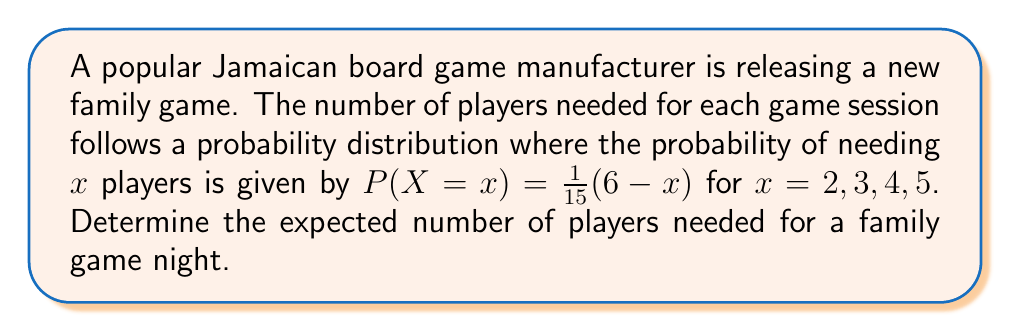Give your solution to this math problem. To find the expected number of players, we need to calculate the expected value of the random variable $X$. The formula for expected value is:

$$E(X) = \sum_{x} x \cdot P(X=x)$$

Let's calculate the probability for each possible number of players:

1. For $x = 2$: $P(X=2) = \frac{1}{15}(6-2) = \frac{4}{15}$
2. For $x = 3$: $P(X=3) = \frac{1}{15}(6-3) = \frac{3}{15}$
3. For $x = 4$: $P(X=4) = \frac{1}{15}(6-4) = \frac{2}{15}$
4. For $x = 5$: $P(X=5) = \frac{1}{15}(6-5) = \frac{1}{15}$

Now, let's calculate the expected value:

$$\begin{align*}
E(X) &= 2 \cdot \frac{4}{15} + 3 \cdot \frac{3}{15} + 4 \cdot \frac{2}{15} + 5 \cdot \frac{1}{15} \\
&= \frac{8}{15} + \frac{9}{15} + \frac{8}{15} + \frac{5}{15} \\
&= \frac{30}{15} \\
&= 3
\end{align*}$$

Therefore, the expected number of players needed for a family game night is 3.
Answer: 3 players 